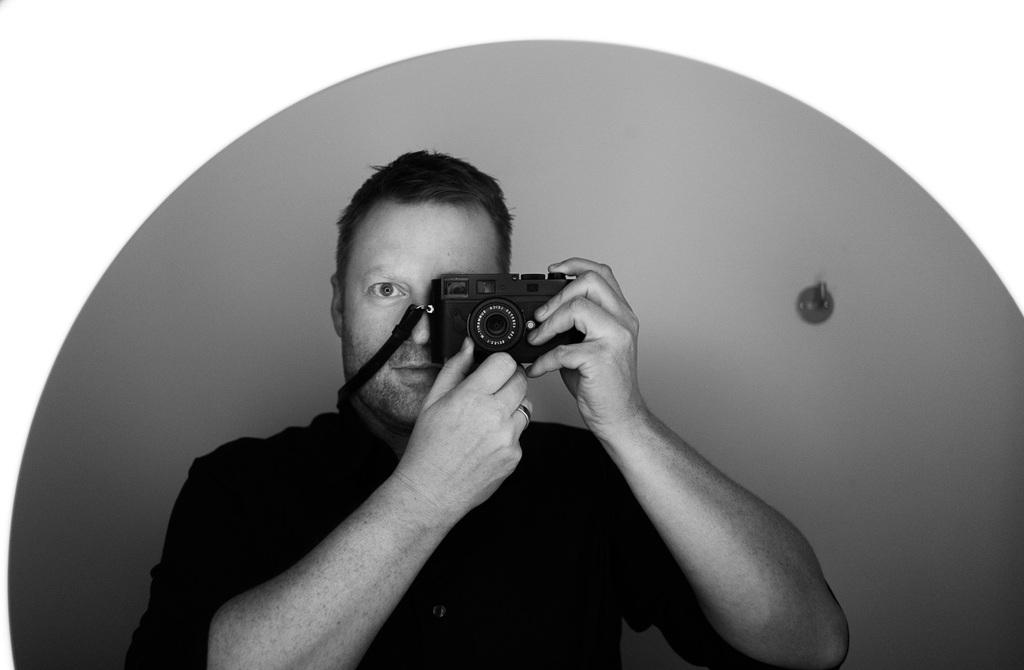What is the color scheme of the image? The image is black and white. Can you describe the person in the image? There is a person in the image, and they are holding a camera near their eye. What is the purpose of the camera in the image? The person is likely using the camera to take a photograph. What can be seen on the right side of the image? There is a holder on the right side of the image. What type of paint is being used by the horse in the image? There is no horse present in the image, and therefore no paint or painting activity can be observed. 